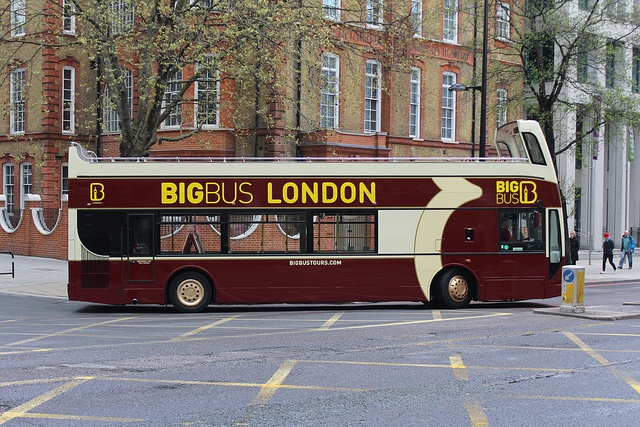Describe the objects in this image and their specific colors. I can see bus in gray, black, maroon, lightgray, and beige tones, people in gray and blue tones, people in gray, black, darkgray, and lightgray tones, people in gray, black, and purple tones, and people in gray, black, and darkgray tones in this image. 